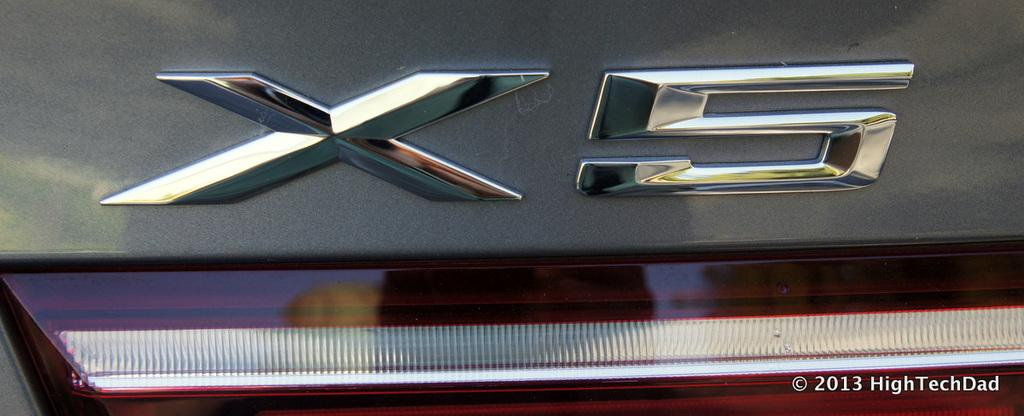What is the main subject of the image? The main subject of the image is a car. What specific feature can be seen on the car? The car has a tail light. Is there any text associated with the tail light? Yes, there is text associated with the tail light. Where is the office located in the image? There is no office present in the image; it features a car with a tail light and associated text. What type of rake is being used to clean the car in the image? There is no rake present in the image; it only shows a car with a tail light and associated text. 